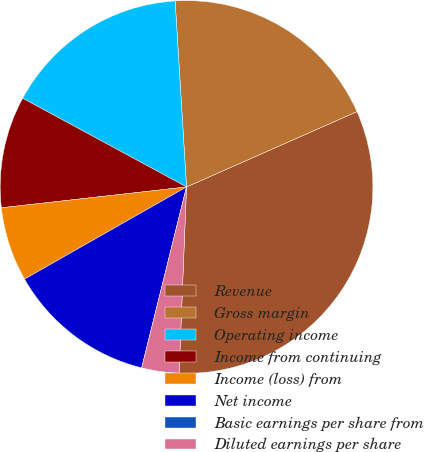Convert chart to OTSL. <chart><loc_0><loc_0><loc_500><loc_500><pie_chart><fcel>Revenue<fcel>Gross margin<fcel>Operating income<fcel>Income from continuing<fcel>Income (loss) from<fcel>Net income<fcel>Basic earnings per share from<fcel>Diluted earnings per share<nl><fcel>32.26%<fcel>19.35%<fcel>16.13%<fcel>9.68%<fcel>6.45%<fcel>12.9%<fcel>0.0%<fcel>3.23%<nl></chart> 